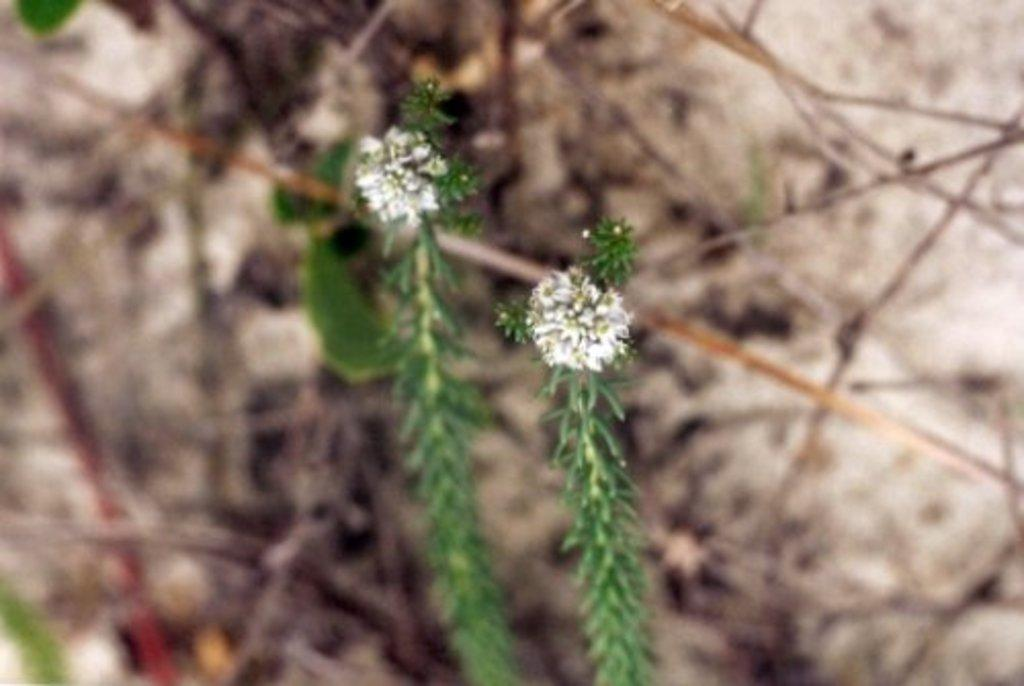What type of plants are visible in the image? There are plants with flowers in the image. Can you describe the background of the image? The background of the image is blurred. How many women are singing in harmony in the image? There are no women or any indication of singing in the image; it features plants with flowers and a blurred background. 